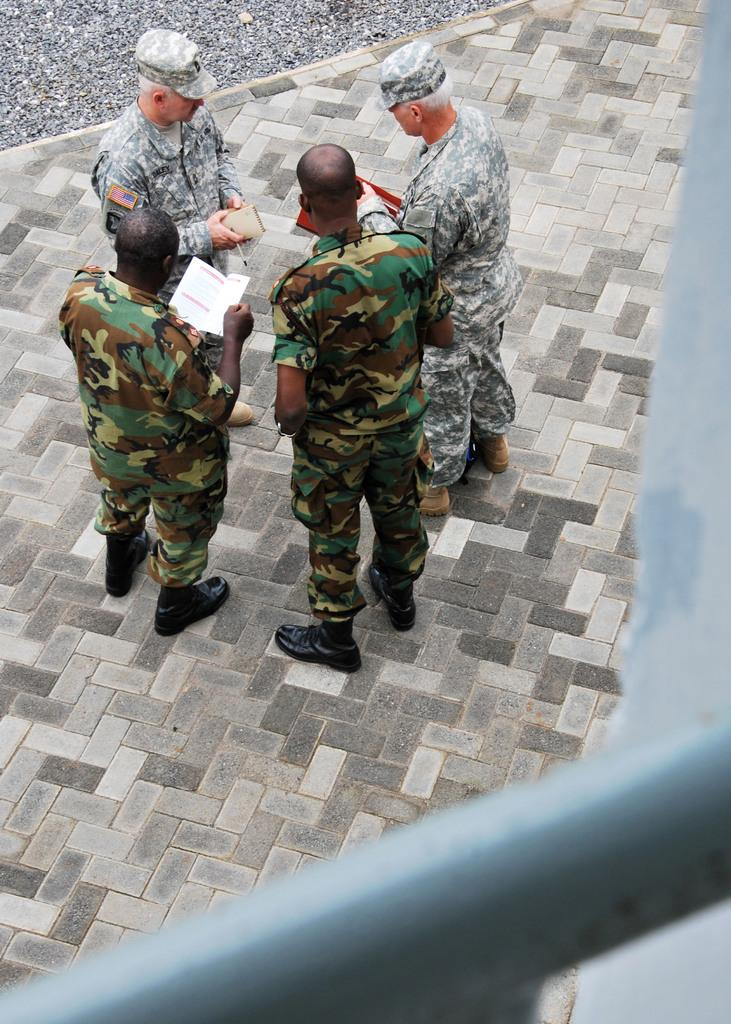How many people are in the image? There are four persons in the image. What are the persons doing in the image? The persons are standing on the floor and holding papers and pens. Can you describe any accessories worn by the persons? Two of the persons are wearing caps. What can be seen at the bottom of the image? There is a rod visible at the bottom of the image. What type of grain is being harvested by the persons in the image? There is no grain or harvesting activity depicted in the image; the persons are holding papers and pens. Can you tell me how many hammers are visible in the image? There are no hammers present in the image. 